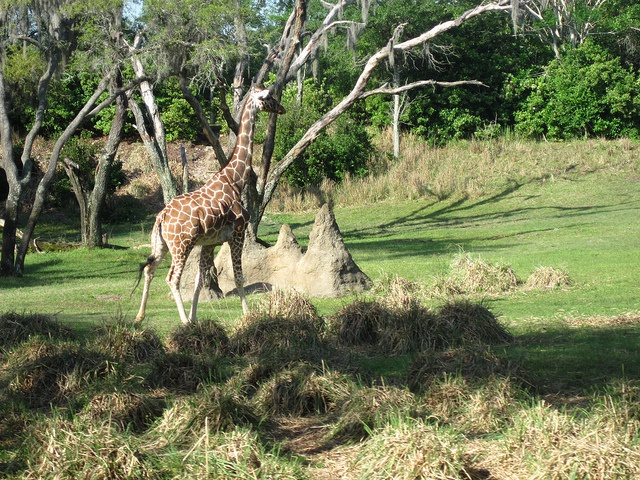Describe the objects in this image and their specific colors. I can see a giraffe in olive, ivory, black, gray, and tan tones in this image. 